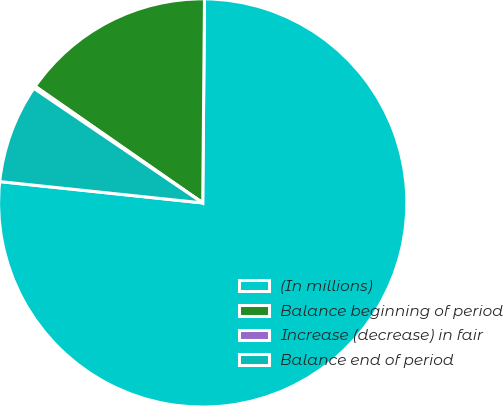Convert chart to OTSL. <chart><loc_0><loc_0><loc_500><loc_500><pie_chart><fcel>(In millions)<fcel>Balance beginning of period<fcel>Increase (decrease) in fair<fcel>Balance end of period<nl><fcel>76.53%<fcel>15.46%<fcel>0.19%<fcel>7.82%<nl></chart> 